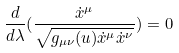Convert formula to latex. <formula><loc_0><loc_0><loc_500><loc_500>\frac { d } { d \lambda } ( \frac { \dot { x } ^ { \mu } } { \sqrt { g _ { \mu \nu } ( u ) \dot { x } ^ { \mu } \dot { x } ^ { \nu } } } ) = 0</formula> 